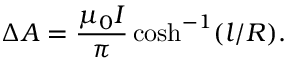Convert formula to latex. <formula><loc_0><loc_0><loc_500><loc_500>\Delta A = \frac { \mu _ { 0 } I } { \pi } \cosh ^ { - 1 } ( l / R ) .</formula> 